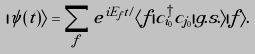Convert formula to latex. <formula><loc_0><loc_0><loc_500><loc_500>| \psi ( t ) \rangle = \sum _ { f } e ^ { i E _ { f } t / } \langle f | c ^ { \dagger } _ { i _ { 0 } } c _ { j _ { 0 } } | g . s . \rangle | f \rangle .</formula> 